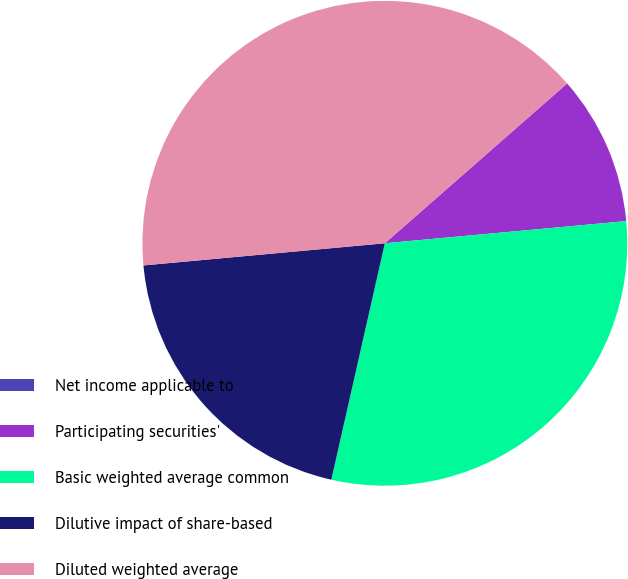Convert chart. <chart><loc_0><loc_0><loc_500><loc_500><pie_chart><fcel>Net income applicable to<fcel>Participating securities'<fcel>Basic weighted average common<fcel>Dilutive impact of share-based<fcel>Diluted weighted average<nl><fcel>0.0%<fcel>10.0%<fcel>30.0%<fcel>20.0%<fcel>40.0%<nl></chart> 